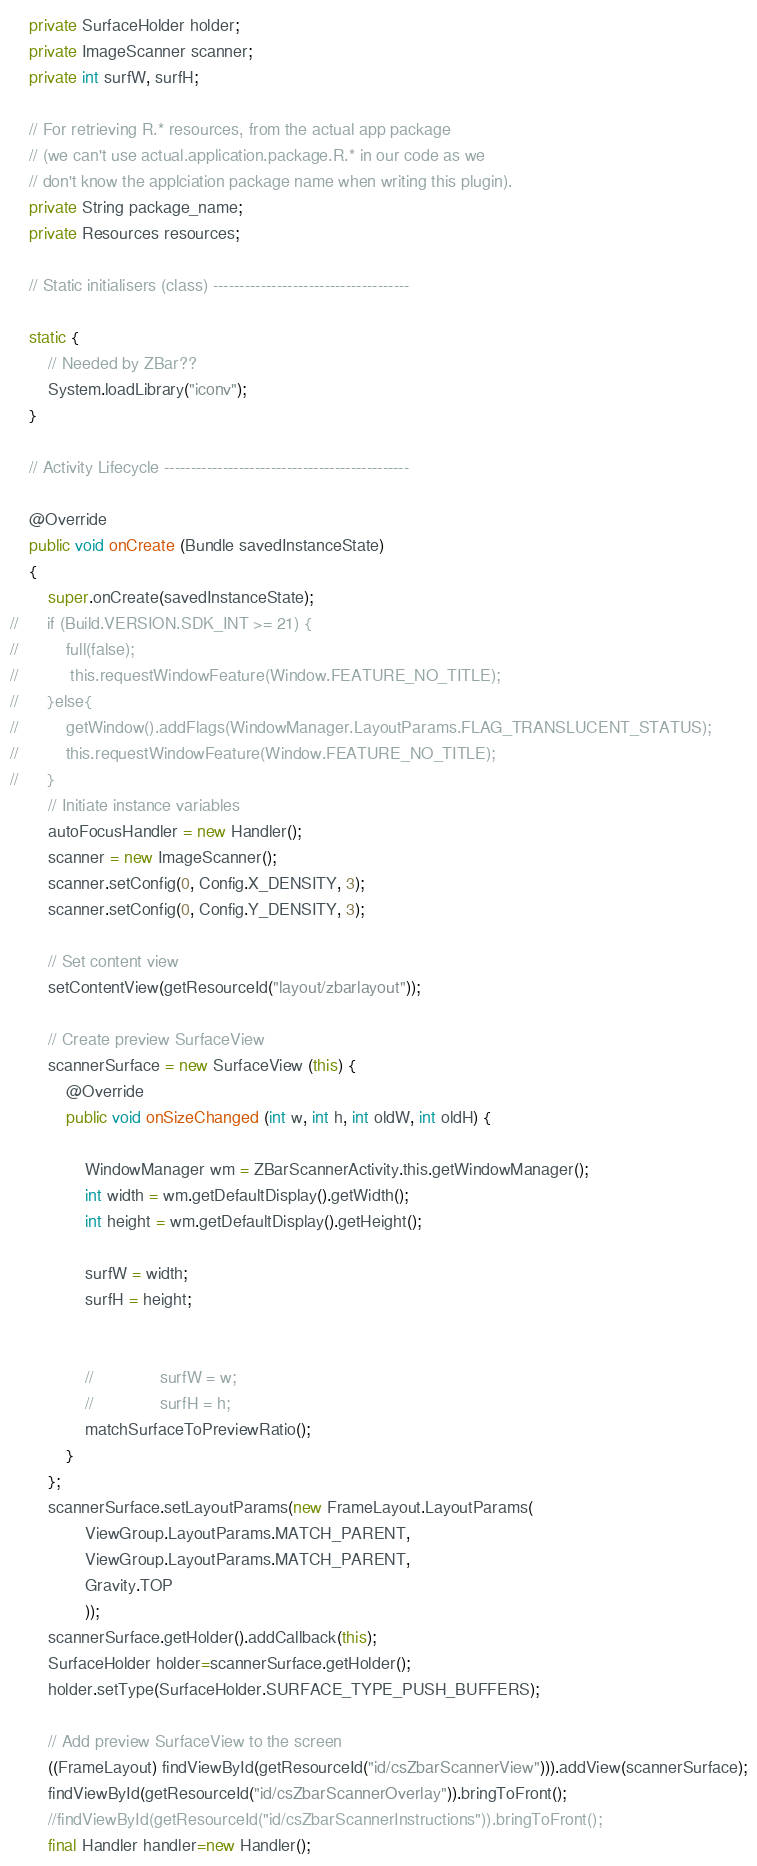<code> <loc_0><loc_0><loc_500><loc_500><_Java_>	private SurfaceHolder holder;
	private ImageScanner scanner;
	private int surfW, surfH;

	// For retrieving R.* resources, from the actual app package
	// (we can't use actual.application.package.R.* in our code as we
	// don't know the applciation package name when writing this plugin).
	private String package_name;
	private Resources resources;

	// Static initialisers (class) -------------------------------------

	static {
		// Needed by ZBar??
		System.loadLibrary("iconv");
	}

	// Activity Lifecycle ----------------------------------------------

	@Override
	public void onCreate (Bundle savedInstanceState)
	{
		super.onCreate(savedInstanceState);
//		if (Build.VERSION.SDK_INT >= 21) {
//			full(false);
//			 this.requestWindowFeature(Window.FEATURE_NO_TITLE);
//		}else{
//	        getWindow().addFlags(WindowManager.LayoutParams.FLAG_TRANSLUCENT_STATUS);
//	        this.requestWindowFeature(Window.FEATURE_NO_TITLE);
//		}
		// Initiate instance variables
		autoFocusHandler = new Handler();
		scanner = new ImageScanner();
		scanner.setConfig(0, Config.X_DENSITY, 3);
		scanner.setConfig(0, Config.Y_DENSITY, 3);

		// Set content view
		setContentView(getResourceId("layout/zbarlayout"));

		// Create preview SurfaceView
		scannerSurface = new SurfaceView (this) {
			@Override
			public void onSizeChanged (int w, int h, int oldW, int oldH) {

				WindowManager wm = ZBarScannerActivity.this.getWindowManager();
				int width = wm.getDefaultDisplay().getWidth();
				int height = wm.getDefaultDisplay().getHeight();

				surfW = width;
				surfH = height;


				//				surfW = w;
				//				surfH = h;
				matchSurfaceToPreviewRatio();
			}
		};
		scannerSurface.setLayoutParams(new FrameLayout.LayoutParams(
				ViewGroup.LayoutParams.MATCH_PARENT,
				ViewGroup.LayoutParams.MATCH_PARENT,
				Gravity.TOP
				));
		scannerSurface.getHolder().addCallback(this);
		SurfaceHolder holder=scannerSurface.getHolder();
		holder.setType(SurfaceHolder.SURFACE_TYPE_PUSH_BUFFERS);

		// Add preview SurfaceView to the screen
		((FrameLayout) findViewById(getResourceId("id/csZbarScannerView"))).addView(scannerSurface);
		findViewById(getResourceId("id/csZbarScannerOverlay")).bringToFront();
		//findViewById(getResourceId("id/csZbarScannerInstructions")).bringToFront();
		final Handler handler=new Handler(); 
</code> 